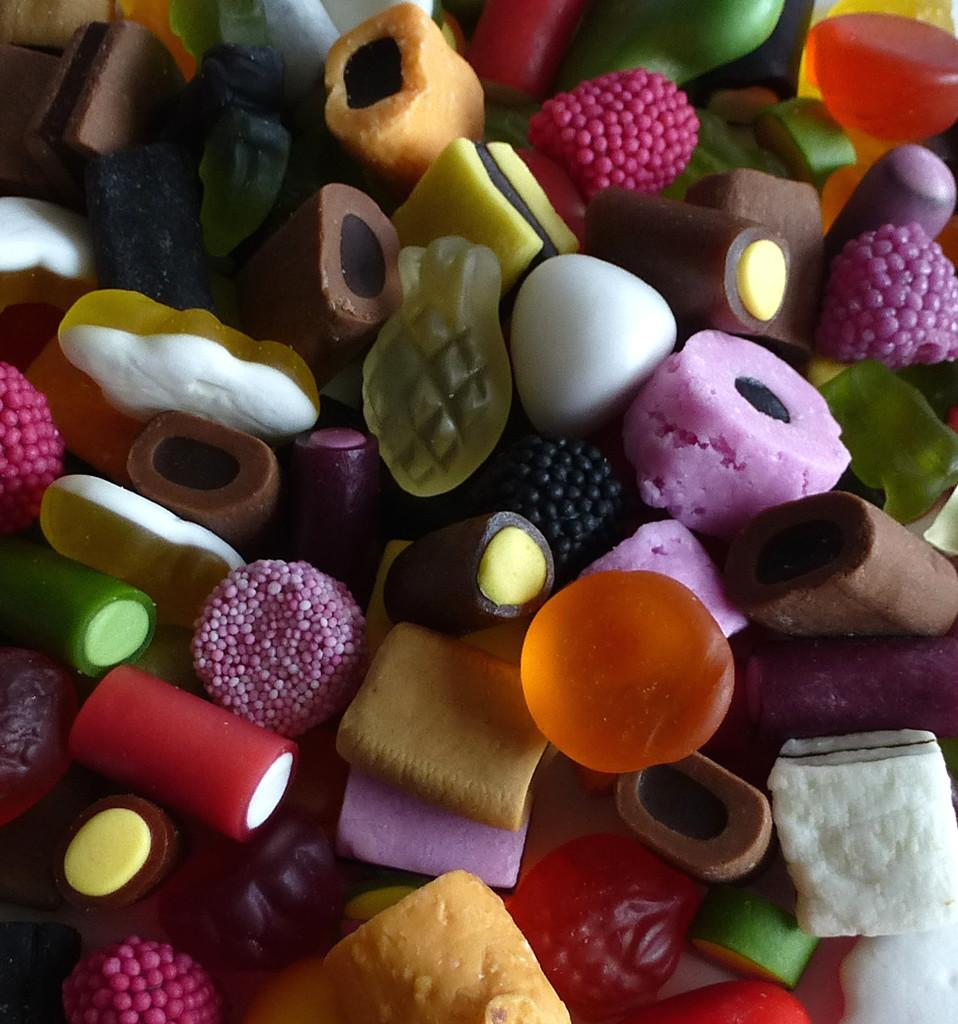What type of objects are present in the image? There are colorful candies in the image. Can you describe the appearance of the candies? The candies are colorful, which suggests they come in various shades and hues. What might be the purpose of these candies? The candies are likely meant for consumption or decoration, given their colorful appearance. How many cattle can be seen grazing in the image? There are no cattle present in the image; it features colorful candies. What type of toy is visible in the image? There is no toy present in the image; it features colorful candies. 